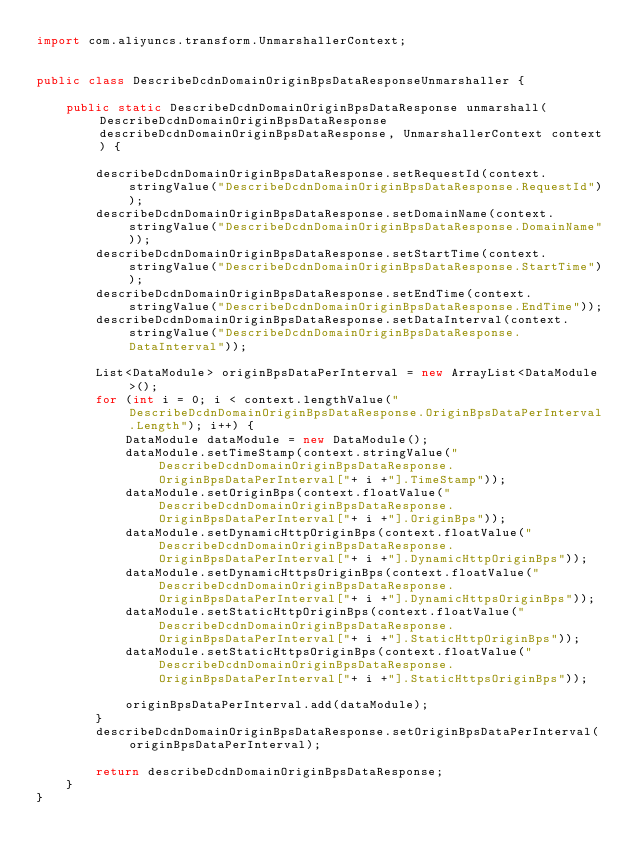Convert code to text. <code><loc_0><loc_0><loc_500><loc_500><_Java_>import com.aliyuncs.transform.UnmarshallerContext;


public class DescribeDcdnDomainOriginBpsDataResponseUnmarshaller {

	public static DescribeDcdnDomainOriginBpsDataResponse unmarshall(DescribeDcdnDomainOriginBpsDataResponse describeDcdnDomainOriginBpsDataResponse, UnmarshallerContext context) {
		
		describeDcdnDomainOriginBpsDataResponse.setRequestId(context.stringValue("DescribeDcdnDomainOriginBpsDataResponse.RequestId"));
		describeDcdnDomainOriginBpsDataResponse.setDomainName(context.stringValue("DescribeDcdnDomainOriginBpsDataResponse.DomainName"));
		describeDcdnDomainOriginBpsDataResponse.setStartTime(context.stringValue("DescribeDcdnDomainOriginBpsDataResponse.StartTime"));
		describeDcdnDomainOriginBpsDataResponse.setEndTime(context.stringValue("DescribeDcdnDomainOriginBpsDataResponse.EndTime"));
		describeDcdnDomainOriginBpsDataResponse.setDataInterval(context.stringValue("DescribeDcdnDomainOriginBpsDataResponse.DataInterval"));

		List<DataModule> originBpsDataPerInterval = new ArrayList<DataModule>();
		for (int i = 0; i < context.lengthValue("DescribeDcdnDomainOriginBpsDataResponse.OriginBpsDataPerInterval.Length"); i++) {
			DataModule dataModule = new DataModule();
			dataModule.setTimeStamp(context.stringValue("DescribeDcdnDomainOriginBpsDataResponse.OriginBpsDataPerInterval["+ i +"].TimeStamp"));
			dataModule.setOriginBps(context.floatValue("DescribeDcdnDomainOriginBpsDataResponse.OriginBpsDataPerInterval["+ i +"].OriginBps"));
			dataModule.setDynamicHttpOriginBps(context.floatValue("DescribeDcdnDomainOriginBpsDataResponse.OriginBpsDataPerInterval["+ i +"].DynamicHttpOriginBps"));
			dataModule.setDynamicHttpsOriginBps(context.floatValue("DescribeDcdnDomainOriginBpsDataResponse.OriginBpsDataPerInterval["+ i +"].DynamicHttpsOriginBps"));
			dataModule.setStaticHttpOriginBps(context.floatValue("DescribeDcdnDomainOriginBpsDataResponse.OriginBpsDataPerInterval["+ i +"].StaticHttpOriginBps"));
			dataModule.setStaticHttpsOriginBps(context.floatValue("DescribeDcdnDomainOriginBpsDataResponse.OriginBpsDataPerInterval["+ i +"].StaticHttpsOriginBps"));

			originBpsDataPerInterval.add(dataModule);
		}
		describeDcdnDomainOriginBpsDataResponse.setOriginBpsDataPerInterval(originBpsDataPerInterval);
	 
	 	return describeDcdnDomainOriginBpsDataResponse;
	}
}</code> 